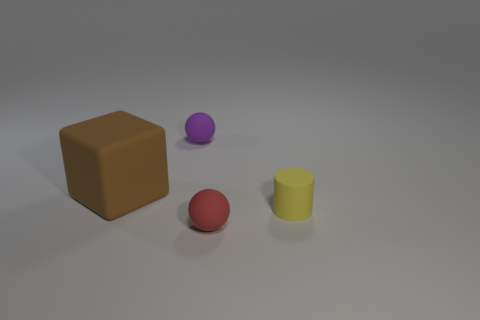Add 2 small purple metal cubes. How many objects exist? 6 Subtract all blocks. How many objects are left? 3 Add 4 red matte balls. How many red matte balls are left? 5 Add 4 big brown cylinders. How many big brown cylinders exist? 4 Subtract 0 gray cubes. How many objects are left? 4 Subtract all large cyan metal objects. Subtract all small spheres. How many objects are left? 2 